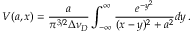<formula> <loc_0><loc_0><loc_500><loc_500>V ( a , x ) = \frac { a } { \pi ^ { 3 / 2 } \Delta \nu _ { D } } \int _ { - \infty } ^ { \infty } \frac { e ^ { - y ^ { 2 } } } { ( x - y ) ^ { 2 } + a ^ { 2 } } d y \, .</formula> 